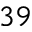<formula> <loc_0><loc_0><loc_500><loc_500>^ { 3 9 }</formula> 